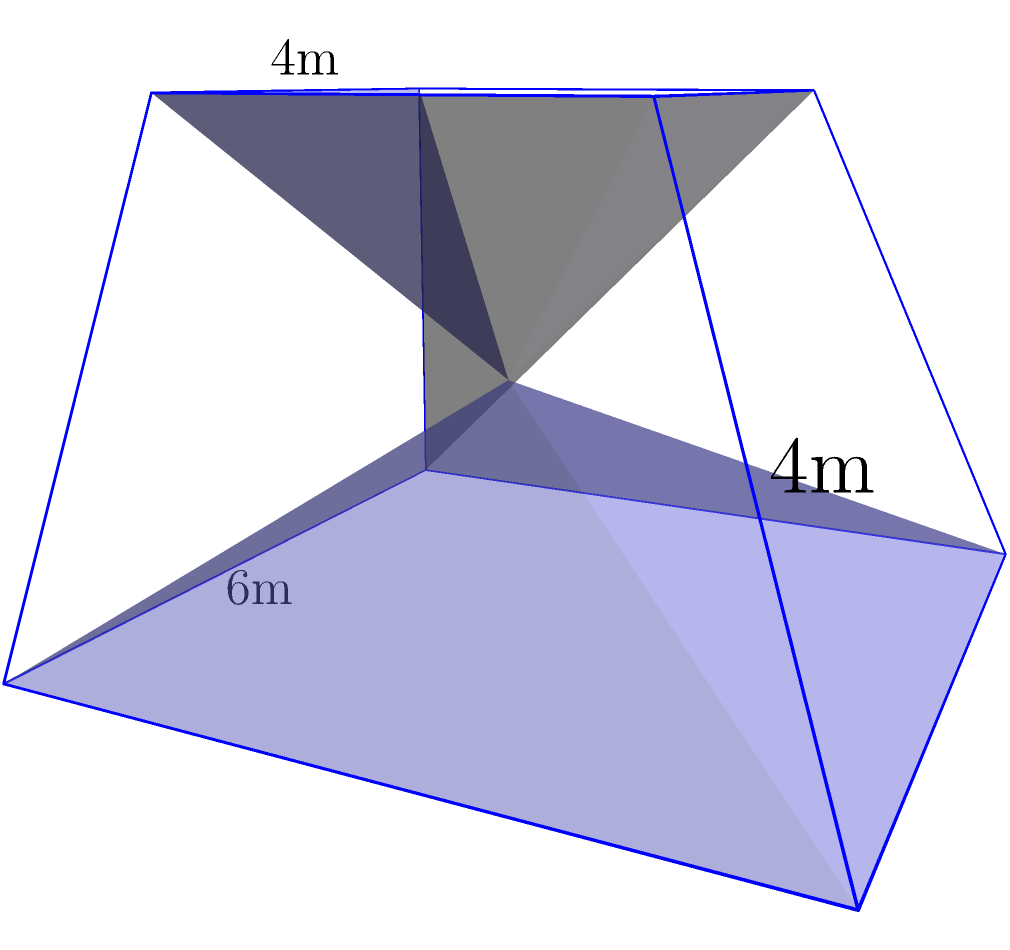As a trainer designing a new stepped platform for exercise routines, you've created a truncated pyramid structure. The base is a square with sides of 6 meters, the top is a square with sides of 4 meters, and the height is 4 meters. Calculate the volume of this truncated pyramid to determine the space it will occupy in the gym. To find the volume of a truncated pyramid, we can use the formula:

$$V = \frac{1}{3}h(A_1 + A_2 + \sqrt{A_1A_2})$$

Where:
$V$ = Volume
$h$ = Height
$A_1$ = Area of the base
$A_2$ = Area of the top

Step 1: Calculate the area of the base ($A_1$)
$A_1 = 6m \times 6m = 36m^2$

Step 2: Calculate the area of the top ($A_2$)
$A_2 = 4m \times 4m = 16m^2$

Step 3: Calculate $\sqrt{A_1A_2}$
$\sqrt{A_1A_2} = \sqrt{36m^2 \times 16m^2} = \sqrt{576m^4} = 24m^2$

Step 4: Apply the formula
$$V = \frac{1}{3} \times 4m(36m^2 + 16m^2 + 24m^2)$$
$$V = \frac{4}{3}m(76m^2)$$
$$V = \frac{304}{3}m^3$$
$$V = 101.33m^3$$

Therefore, the volume of the truncated pyramid is approximately 101.33 cubic meters.
Answer: 101.33 m³ 